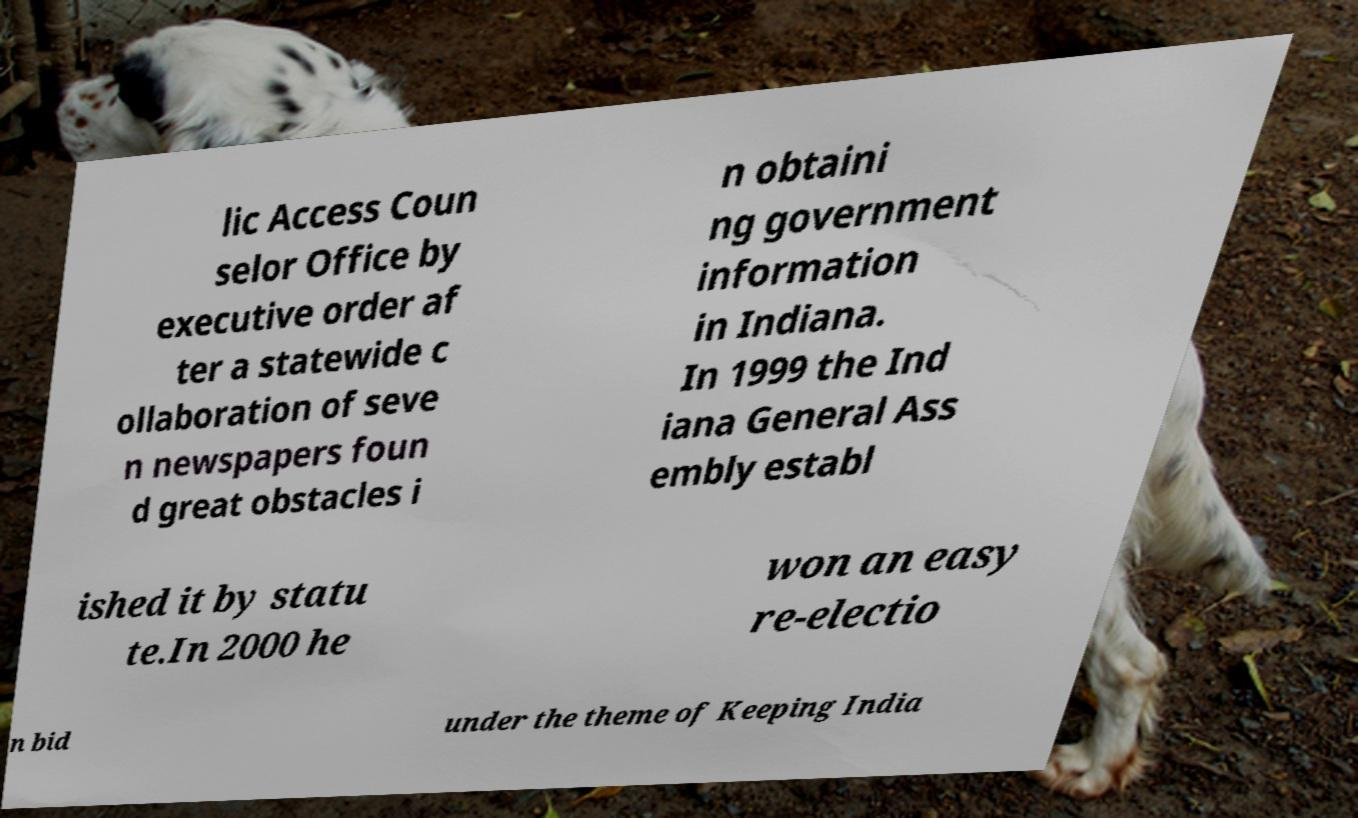Could you assist in decoding the text presented in this image and type it out clearly? lic Access Coun selor Office by executive order af ter a statewide c ollaboration of seve n newspapers foun d great obstacles i n obtaini ng government information in Indiana. In 1999 the Ind iana General Ass embly establ ished it by statu te.In 2000 he won an easy re-electio n bid under the theme of Keeping India 